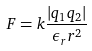Convert formula to latex. <formula><loc_0><loc_0><loc_500><loc_500>F = k \frac { | q _ { 1 } q _ { 2 } | } { \epsilon _ { r } r ^ { 2 } }</formula> 